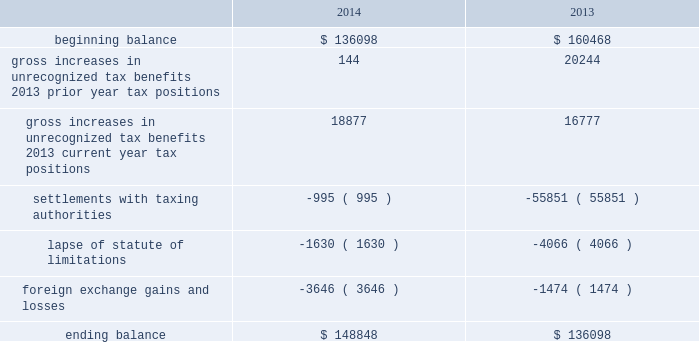Adobe systems incorporated notes to consolidated financial statements ( continued ) accounting for uncertainty in income taxes during fiscal 2014 and 2013 , our aggregate changes in our total gross amount of unrecognized tax benefits are summarized as follows ( in thousands ) : .
As of november 28 , 2014 , the combined amount of accrued interest and penalties related to tax positions taken on our tax returns and included in non-current income taxes payable was approximately $ 14.6 million .
We file income tax returns in the u.s .
On a federal basis and in many u.s .
State and foreign jurisdictions .
We are subject to the continual examination of our income tax returns by the irs and other domestic and foreign tax authorities .
Our major tax jurisdictions are ireland , california and the u.s .
For ireland , california and the u.s. , the earliest fiscal years open for examination are 2008 , 2008 and 2010 , respectively .
We regularly assess the likelihood of outcomes resulting from these examinations to determine the adequacy of our provision for income taxes and have reserved for potential adjustments that may result from the current examinations .
We believe such estimates to be reasonable ; however , there can be no assurance that the final determination of any of these examinations will not have an adverse effect on our operating results and financial position .
In july 2013 , a u.s .
Income tax examination covering fiscal 2008 and 2009 was completed .
Our accrued tax and interest related to these years was $ 48.4 million and was previously reported in long-term income taxes payable .
We settled the tax obligation resulting from this examination with cash and income tax assets totaling $ 41.2 million , and the resulting $ 7.2 million income tax benefit was recorded in the third quarter of fiscal 2013 .
The timing of the resolution of income tax examinations is highly uncertain as are the amounts and timing of tax payments that are part of any audit settlement process .
These events could cause large fluctuations in the balance sheet classification of current and non-current assets and liabilities .
We believe that within the next 12 months , it is reasonably possible that either certain audits will conclude or statutes of limitations on certain income tax examination periods will expire , or both .
Given the uncertainties described above , we can only determine a range of estimated potential decreases in underlying unrecognized tax benefits ranging from $ 0 to approximately $ 5 million .
Note 10 .
Restructuring fiscal 2014 restructuring plan in the fourth quarter of fiscal 2014 , in order to better align our global resources for digital media and digital marketing , we initiated a restructuring plan to vacate our research and development facility in china and our sales and marketing facility in russia .
This plan consisted of reductions of approximately 350 full-time positions and we recorded restructuring charges of approximately $ 18.8 million related to ongoing termination benefits for the positions eliminated .
During fiscal 2015 , we intend to vacate both of these facilities .
The amount accrued for the fair value of future contractual obligations under these operating leases was insignificant .
Other restructuring plans during the past several years , we have implemented other restructuring plans consisting of reductions in workforce and the consolidation of facilities to better align our resources around our business strategies .
As of november 28 , 2014 , we considered our other restructuring plans to be substantially complete .
We continue to make cash outlays to settle obligations under these plans , however the current impact to our consolidated financial statements is not significant. .
In thousands , what was the change between years in gross increases in unrecognized tax benefits 2013 prior year tax positions? 
Computations: (144 - 20244)
Answer: -20100.0. Adobe systems incorporated notes to consolidated financial statements ( continued ) accounting for uncertainty in income taxes during fiscal 2014 and 2013 , our aggregate changes in our total gross amount of unrecognized tax benefits are summarized as follows ( in thousands ) : .
As of november 28 , 2014 , the combined amount of accrued interest and penalties related to tax positions taken on our tax returns and included in non-current income taxes payable was approximately $ 14.6 million .
We file income tax returns in the u.s .
On a federal basis and in many u.s .
State and foreign jurisdictions .
We are subject to the continual examination of our income tax returns by the irs and other domestic and foreign tax authorities .
Our major tax jurisdictions are ireland , california and the u.s .
For ireland , california and the u.s. , the earliest fiscal years open for examination are 2008 , 2008 and 2010 , respectively .
We regularly assess the likelihood of outcomes resulting from these examinations to determine the adequacy of our provision for income taxes and have reserved for potential adjustments that may result from the current examinations .
We believe such estimates to be reasonable ; however , there can be no assurance that the final determination of any of these examinations will not have an adverse effect on our operating results and financial position .
In july 2013 , a u.s .
Income tax examination covering fiscal 2008 and 2009 was completed .
Our accrued tax and interest related to these years was $ 48.4 million and was previously reported in long-term income taxes payable .
We settled the tax obligation resulting from this examination with cash and income tax assets totaling $ 41.2 million , and the resulting $ 7.2 million income tax benefit was recorded in the third quarter of fiscal 2013 .
The timing of the resolution of income tax examinations is highly uncertain as are the amounts and timing of tax payments that are part of any audit settlement process .
These events could cause large fluctuations in the balance sheet classification of current and non-current assets and liabilities .
We believe that within the next 12 months , it is reasonably possible that either certain audits will conclude or statutes of limitations on certain income tax examination periods will expire , or both .
Given the uncertainties described above , we can only determine a range of estimated potential decreases in underlying unrecognized tax benefits ranging from $ 0 to approximately $ 5 million .
Note 10 .
Restructuring fiscal 2014 restructuring plan in the fourth quarter of fiscal 2014 , in order to better align our global resources for digital media and digital marketing , we initiated a restructuring plan to vacate our research and development facility in china and our sales and marketing facility in russia .
This plan consisted of reductions of approximately 350 full-time positions and we recorded restructuring charges of approximately $ 18.8 million related to ongoing termination benefits for the positions eliminated .
During fiscal 2015 , we intend to vacate both of these facilities .
The amount accrued for the fair value of future contractual obligations under these operating leases was insignificant .
Other restructuring plans during the past several years , we have implemented other restructuring plans consisting of reductions in workforce and the consolidation of facilities to better align our resources around our business strategies .
As of november 28 , 2014 , we considered our other restructuring plans to be substantially complete .
We continue to make cash outlays to settle obligations under these plans , however the current impact to our consolidated financial statements is not significant. .
What is the percentage change in the total gross amount of unrecognized tax benefits from 2012 to 2013? 
Computations: ((136098 - 160468) / 160468)
Answer: -0.15187. 